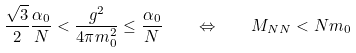Convert formula to latex. <formula><loc_0><loc_0><loc_500><loc_500>\frac { \sqrt { 3 } } { 2 } \frac { \alpha _ { 0 } } { N } < \frac { g ^ { 2 } } { 4 \pi m _ { 0 } ^ { 2 } } \leq \frac { \alpha _ { 0 } } { N } \quad \Leftrightarrow \quad M _ { N N } < N m _ { 0 }</formula> 